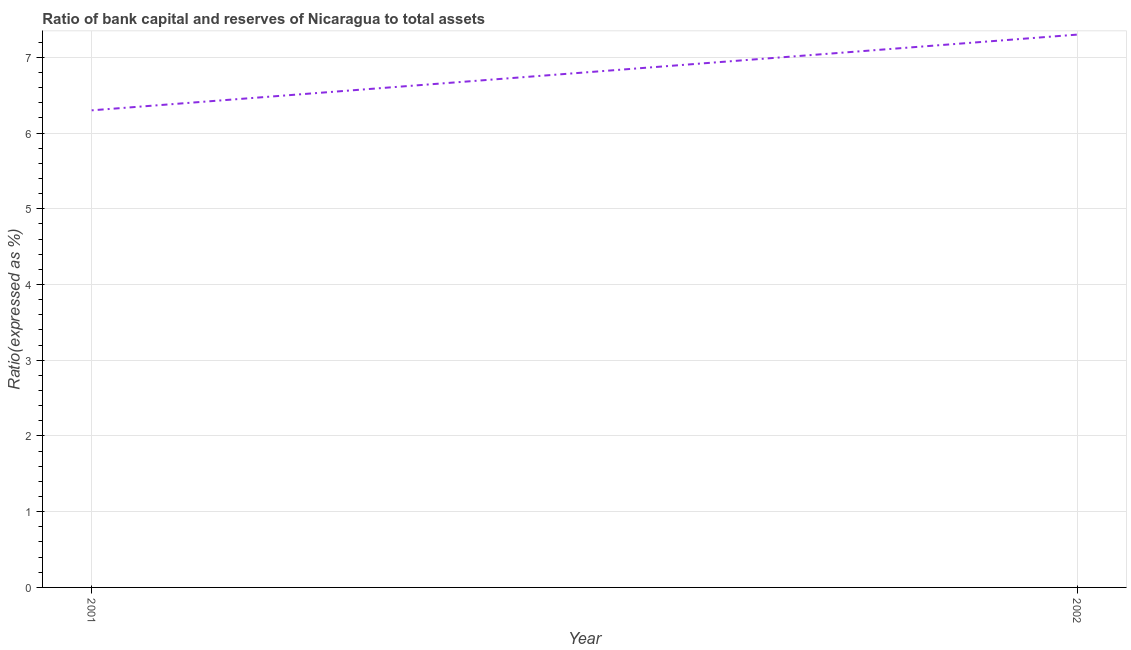What is the bank capital to assets ratio in 2002?
Ensure brevity in your answer.  7.3. Across all years, what is the minimum bank capital to assets ratio?
Give a very brief answer. 6.3. In which year was the bank capital to assets ratio minimum?
Your answer should be compact. 2001. What is the sum of the bank capital to assets ratio?
Your answer should be compact. 13.6. What is the average bank capital to assets ratio per year?
Ensure brevity in your answer.  6.8. What is the median bank capital to assets ratio?
Ensure brevity in your answer.  6.8. What is the ratio of the bank capital to assets ratio in 2001 to that in 2002?
Offer a very short reply. 0.86. Is the bank capital to assets ratio in 2001 less than that in 2002?
Make the answer very short. Yes. What is the difference between two consecutive major ticks on the Y-axis?
Make the answer very short. 1. What is the title of the graph?
Make the answer very short. Ratio of bank capital and reserves of Nicaragua to total assets. What is the label or title of the X-axis?
Give a very brief answer. Year. What is the label or title of the Y-axis?
Keep it short and to the point. Ratio(expressed as %). What is the Ratio(expressed as %) in 2002?
Make the answer very short. 7.3. What is the difference between the Ratio(expressed as %) in 2001 and 2002?
Your answer should be very brief. -1. What is the ratio of the Ratio(expressed as %) in 2001 to that in 2002?
Give a very brief answer. 0.86. 